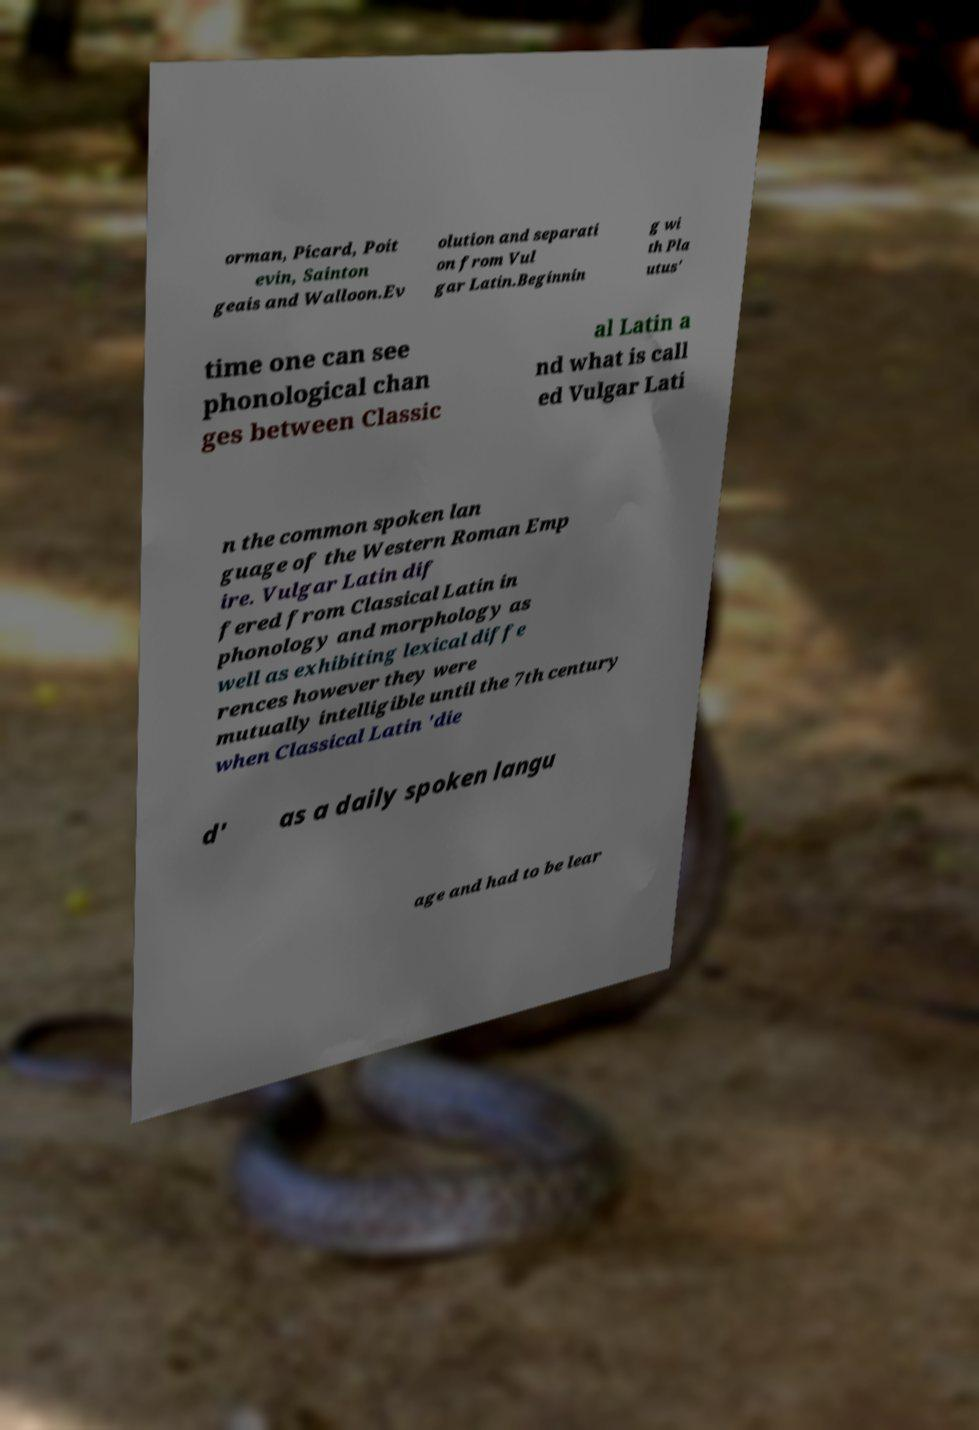What messages or text are displayed in this image? I need them in a readable, typed format. orman, Picard, Poit evin, Sainton geais and Walloon.Ev olution and separati on from Vul gar Latin.Beginnin g wi th Pla utus' time one can see phonological chan ges between Classic al Latin a nd what is call ed Vulgar Lati n the common spoken lan guage of the Western Roman Emp ire. Vulgar Latin dif fered from Classical Latin in phonology and morphology as well as exhibiting lexical diffe rences however they were mutually intelligible until the 7th century when Classical Latin 'die d' as a daily spoken langu age and had to be lear 